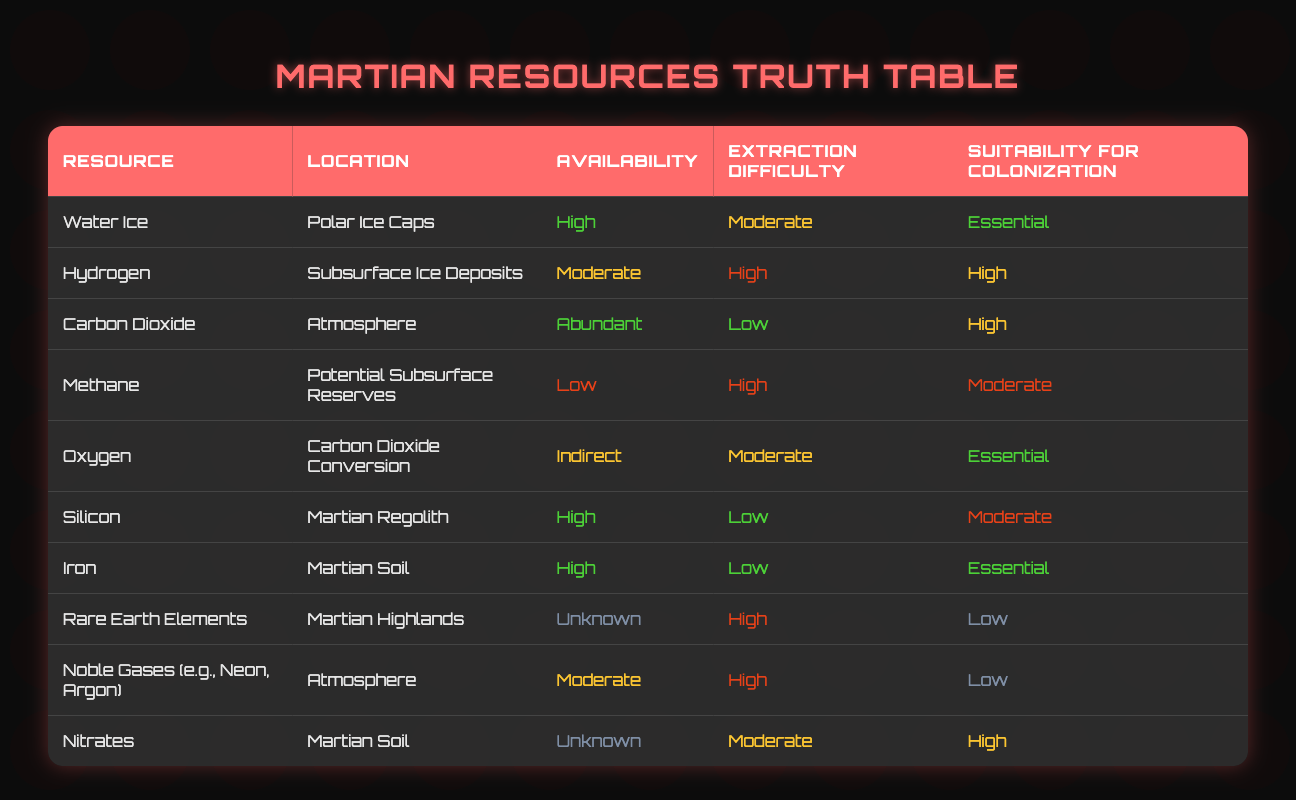What is the extraction difficulty of Water Ice? Water Ice has "Moderate" listed as its extraction difficulty according to the table. This is retrieved directly from the corresponding row for Water Ice.
Answer: Moderate Which resource has "High" suitability for colonization and "High" availability? Hydrogen is the resource that has "High" suitability for colonization and "Moderate" availability. It is verified by checking both the suitability and availability columns for Hydrogen.
Answer: No What is the extraction difficulty of resources that are essential for colonization? The essential resources - Water Ice, Oxygen, and Iron have extraction difficulties of Moderate and Low. Water Ice and Oxygen have Moderate, while Iron has Low as per their respective rows.
Answer: Moderate, Low Which resource located in the atmosphere is abundant? The resource in the atmosphere that is abundant is Carbon Dioxide. This can be found in the table by filtering by location and checking the availability status.
Answer: Carbon Dioxide Is there a resource with unknown availability that has low suitability for colonization? Yes, the resource called Rare Earth Elements has an unknown availability and is rated low on suitability for colonization. This is identified directly in the table under the respective rows.
Answer: Yes What is the average extraction difficulty of resources with "High" suitability for colonization? Three resources (Hydrogen, Carbon Dioxide, and Nitrates) have "High" suitability. Their extraction difficulties are "High," "Low," and "Moderate," respectively. The average extraction difficulty is calculated as (High, Low, Moderate) represented numerically as (3, 1, 2) gives an average of (3 + 1 + 2)/3 = 2. Thus, the average difficulty level is Moderate.
Answer: Moderate Which resource has the lowest availability and what is its extraction difficulty? The resource with the lowest availability is Methane, which has a "Low" availability status and a "High" extraction difficulty. This is confirmed by checking the Methane entry in the table.
Answer: Methane; High Are there more resources with essential suitability or low suitability for colonization? There are four resources with essential suitability (Water Ice, Oxygen, Iron) and three resources with low suitability (Rare Earth Elements, Noble Gases, and Nitrates). A simple comparison shows that there are more essential resources than low suitability ones.
Answer: Essential resources What is the extraction difficulty of resources that are challenging to extract? The resources listed with high extraction difficulty are Hydrogen, Methane, Rare Earth Elements, and Noble Gases. According to their respective rows, the extraction difficulties are "High" for all of them.
Answer: High 